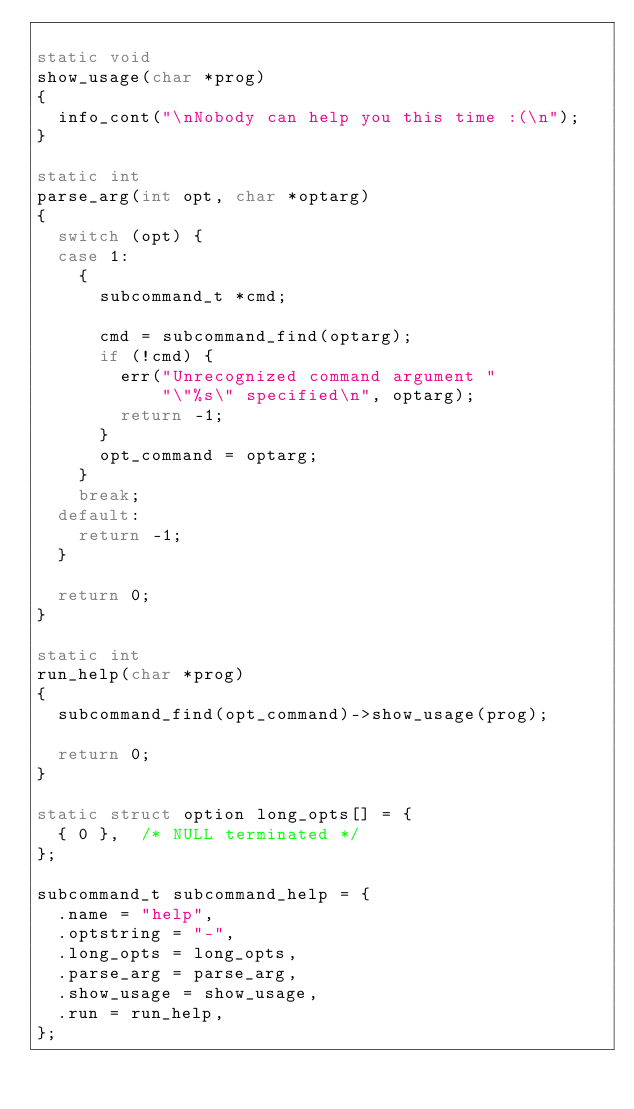Convert code to text. <code><loc_0><loc_0><loc_500><loc_500><_C_>
static void
show_usage(char *prog)
{
	info_cont("\nNobody can help you this time :(\n");
}

static int
parse_arg(int opt, char *optarg)
{
	switch (opt) {
	case 1:
		{
			subcommand_t *cmd;

			cmd = subcommand_find(optarg);
			if (!cmd) {
				err("Unrecognized command argument "
				    "\"%s\" specified\n", optarg);
				return -1;
			}
			opt_command = optarg;
		}
		break;
	default:
		return -1;
	}

	return 0;
}

static int
run_help(char *prog)
{
	subcommand_find(opt_command)->show_usage(prog);

	return 0;
}

static struct option long_opts[] = {
	{ 0 },	/* NULL terminated */
};

subcommand_t subcommand_help = {
	.name = "help",
	.optstring = "-",
	.long_opts = long_opts,
	.parse_arg = parse_arg,
	.show_usage = show_usage,
	.run = run_help,
};</code> 